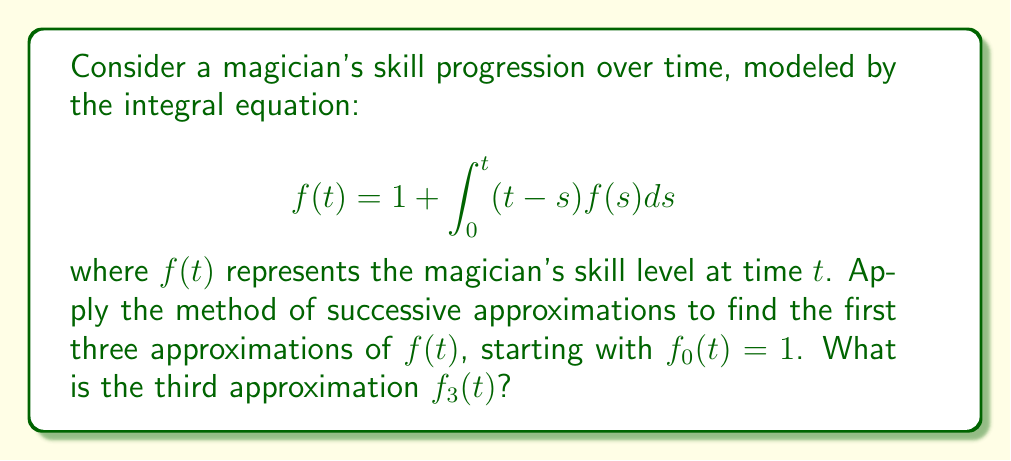What is the answer to this math problem? Let's apply the method of successive approximations:

1) Start with $f_0(t) = 1$

2) For the first approximation:
   $$f_1(t) = 1 + \int_0^t (t-s)f_0(s)ds = 1 + \int_0^t (t-s)ds = 1 + [ts - \frac{s^2}{2}]_0^t = 1 + t^2 - \frac{t^2}{2} = 1 + \frac{t^2}{2}$$

3) For the second approximation:
   $$\begin{align*}
   f_2(t) &= 1 + \int_0^t (t-s)f_1(s)ds \\
   &= 1 + \int_0^t (t-s)(1 + \frac{s^2}{2})ds \\
   &= 1 + \int_0^t (t-s + \frac{ts^2}{2} - \frac{s^3}{2})ds \\
   &= 1 + [ts - \frac{s^2}{2} + \frac{ts^3}{6} - \frac{s^4}{8}]_0^t \\
   &= 1 + t^2 - \frac{t^2}{2} + \frac{t^4}{6} - \frac{t^4}{8} \\
   &= 1 + \frac{t^2}{2} + \frac{t^4}{24}
   \end{align*}$$

4) For the third approximation:
   $$\begin{align*}
   f_3(t) &= 1 + \int_0^t (t-s)f_2(s)ds \\
   &= 1 + \int_0^t (t-s)(1 + \frac{s^2}{2} + \frac{s^4}{24})ds \\
   &= 1 + \int_0^t (t-s + \frac{ts^2}{2} - \frac{s^3}{2} + \frac{ts^4}{24} - \frac{s^5}{24})ds \\
   &= 1 + [ts - \frac{s^2}{2} + \frac{ts^3}{6} - \frac{s^4}{8} + \frac{ts^5}{120} - \frac{s^6}{144}]_0^t \\
   &= 1 + t^2 - \frac{t^2}{2} + \frac{t^4}{6} - \frac{t^4}{8} + \frac{t^6}{120} - \frac{t^6}{144} \\
   &= 1 + \frac{t^2}{2} + \frac{t^4}{24} + \frac{t^6}{720}
   \end{align*}$$
Answer: $f_3(t) = 1 + \frac{t^2}{2} + \frac{t^4}{24} + \frac{t^6}{720}$ 